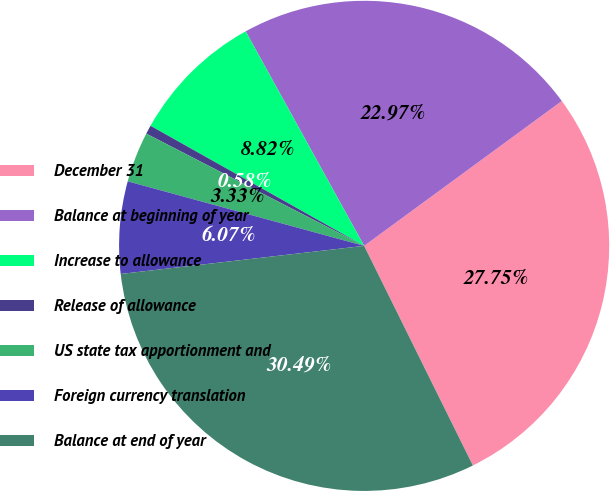Convert chart to OTSL. <chart><loc_0><loc_0><loc_500><loc_500><pie_chart><fcel>December 31<fcel>Balance at beginning of year<fcel>Increase to allowance<fcel>Release of allowance<fcel>US state tax apportionment and<fcel>Foreign currency translation<fcel>Balance at end of year<nl><fcel>27.75%<fcel>22.97%<fcel>8.82%<fcel>0.58%<fcel>3.33%<fcel>6.07%<fcel>30.49%<nl></chart> 